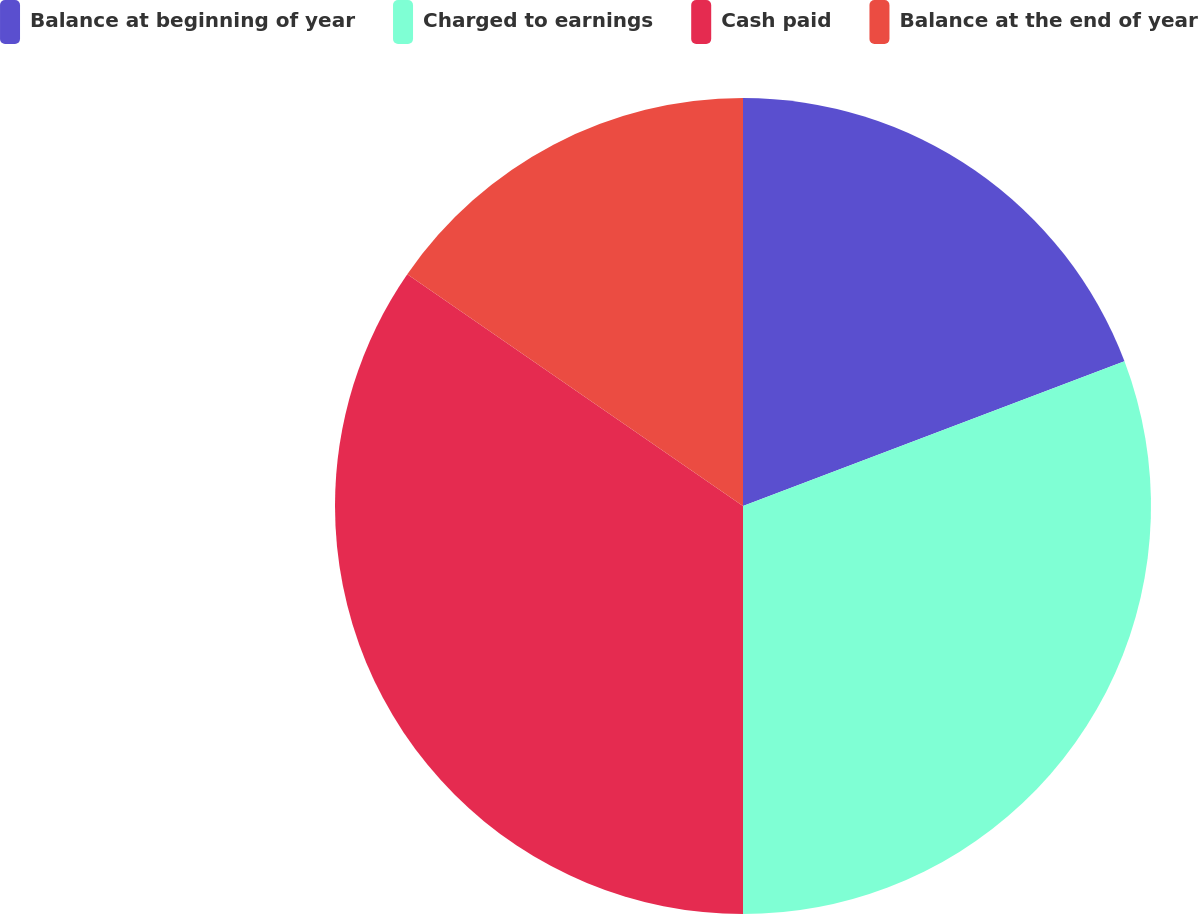<chart> <loc_0><loc_0><loc_500><loc_500><pie_chart><fcel>Balance at beginning of year<fcel>Charged to earnings<fcel>Cash paid<fcel>Balance at the end of year<nl><fcel>19.23%<fcel>30.77%<fcel>34.62%<fcel>15.38%<nl></chart> 